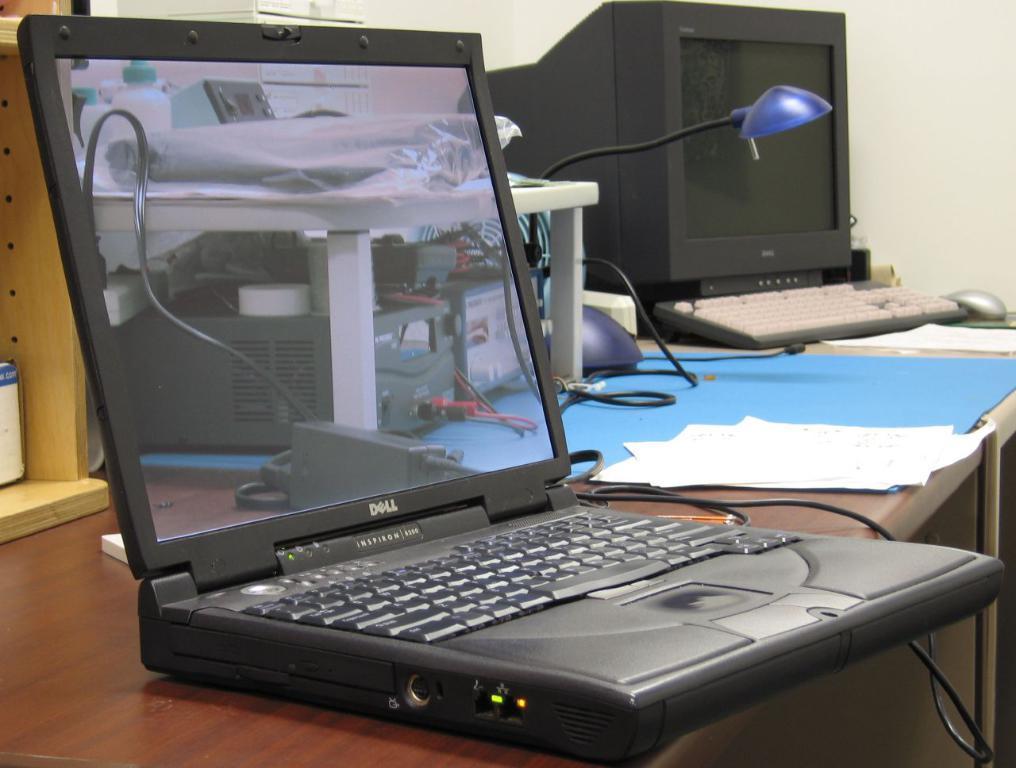Could you give a brief overview of what you see in this image? In this picture I can see a table in front on which there is a laptop, a monitor, a keyboard, a mouse, a lamp, few papers and other things. In the background I can see the wall. On the screen of the laptop I can see the reflection of few electronic equipment and wires. 